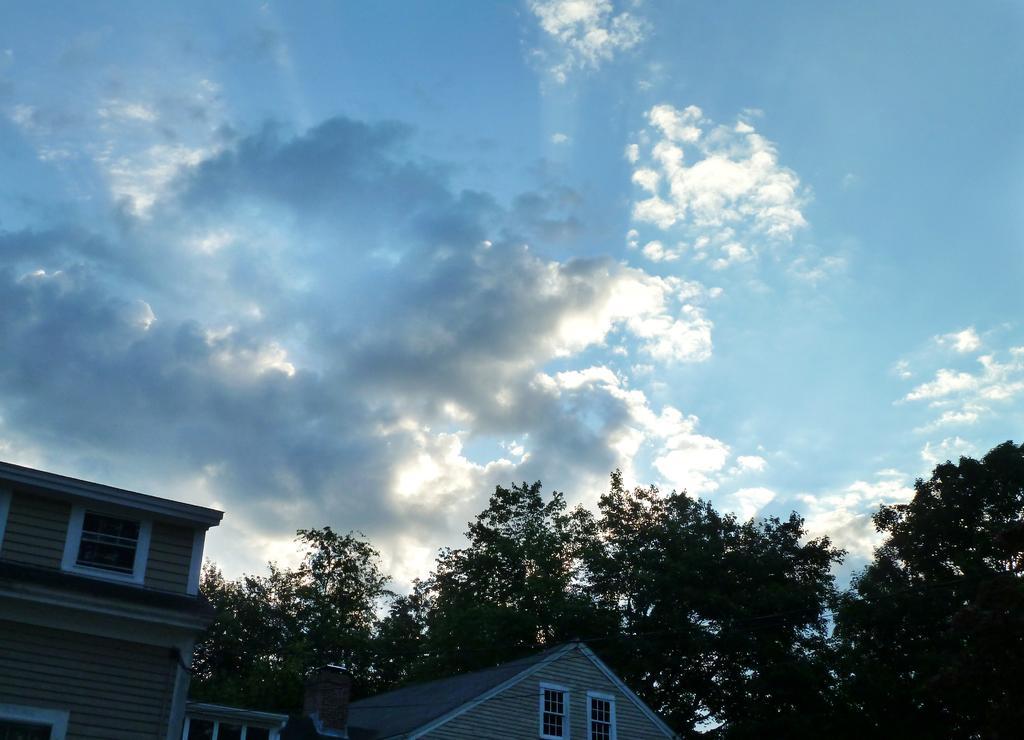Please provide a concise description of this image. In this image, we can see buildings and trees and at the top, there are clouds in the sky. 